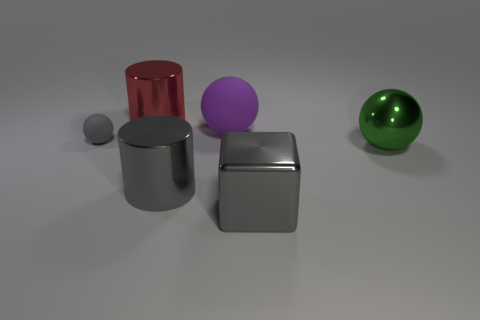What is the lighting like in this scene? The lighting is soft and diffused, coming from above. It casts gentle shadows beneath the objects, suggesting the light source is not too harsh. This kind of lighting creates a pleasant, almost studio-like environment for the objects. What could you infer about the setting from this lighting? Based on the lighting and the objects' arrangements, one could infer that this scene is set up in a controlled environment, likely a studio for 3D modeling or product visualization. The aim is to highlight the form and materials of the objects without creating any distracting shadows or reflections. 